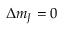Convert formula to latex. <formula><loc_0><loc_0><loc_500><loc_500>\Delta m _ { J } = 0</formula> 